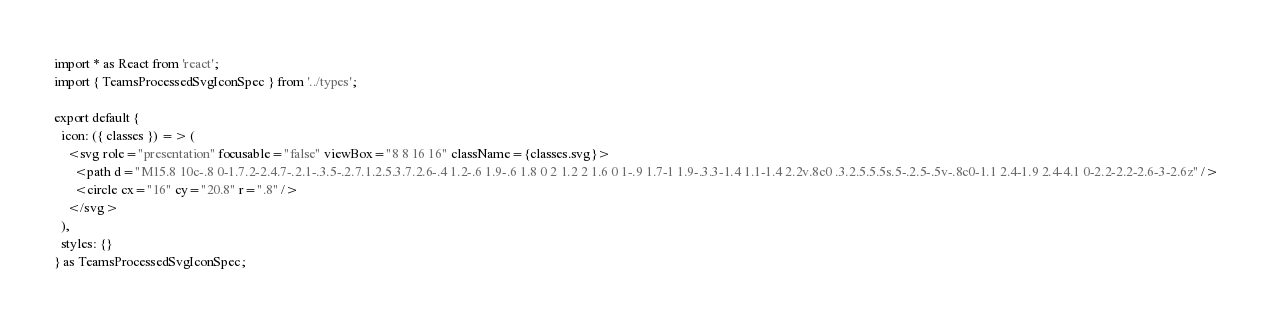Convert code to text. <code><loc_0><loc_0><loc_500><loc_500><_TypeScript_>import * as React from 'react';
import { TeamsProcessedSvgIconSpec } from '../types';

export default {
  icon: ({ classes }) => (
    <svg role="presentation" focusable="false" viewBox="8 8 16 16" className={classes.svg}>
      <path d="M15.8 10c-.8 0-1.7.2-2.4.7-.2.1-.3.5-.2.7.1.2.5.3.7.2.6-.4 1.2-.6 1.9-.6 1.8 0 2 1.2 2 1.6 0 1-.9 1.7-1 1.9-.3.3-1.4 1.1-1.4 2.2v.8c0 .3.2.5.5.5s.5-.2.5-.5v-.8c0-1.1 2.4-1.9 2.4-4.1 0-2.2-2.2-2.6-3-2.6z" />
      <circle cx="16" cy="20.8" r=".8" />
    </svg>
  ),
  styles: {}
} as TeamsProcessedSvgIconSpec;
</code> 